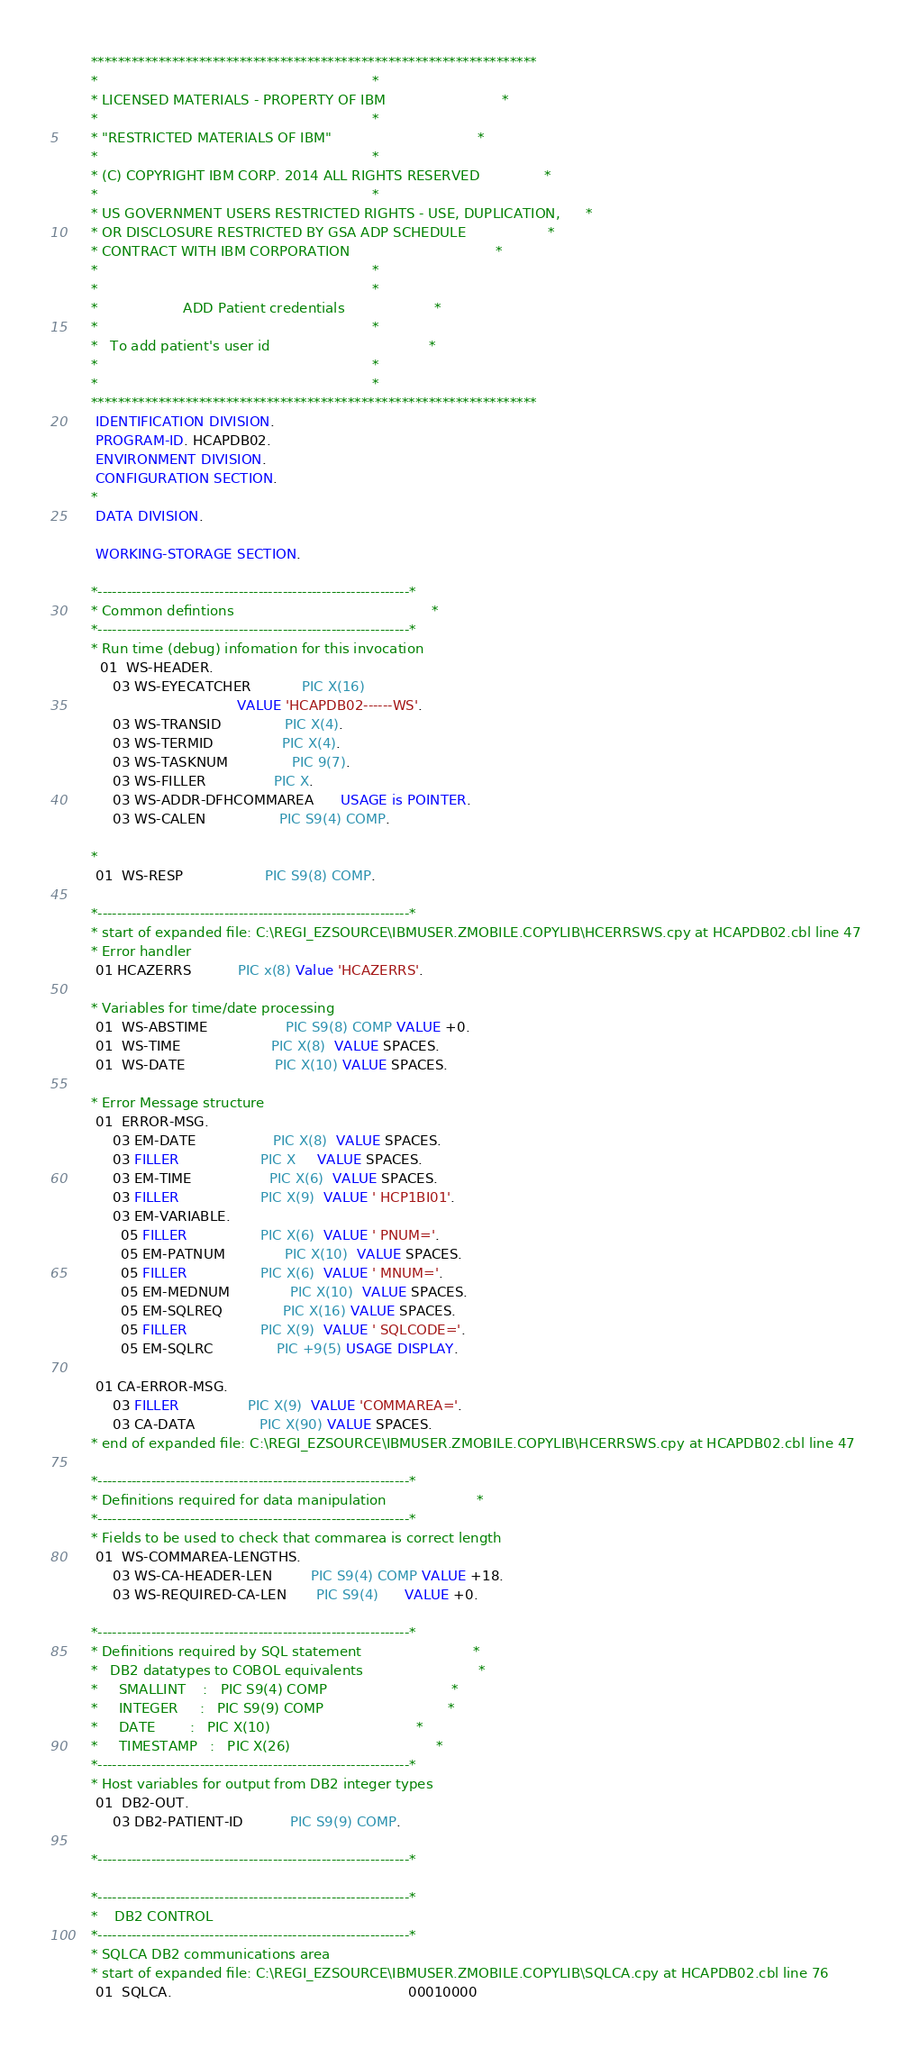Convert code to text. <code><loc_0><loc_0><loc_500><loc_500><_COBOL_>      ******************************************************************
      *                                                                *
      * LICENSED MATERIALS - PROPERTY OF IBM                           *
      *                                                                *
      * "RESTRICTED MATERIALS OF IBM"                                  *
      *                                                                *
      * (C) COPYRIGHT IBM CORP. 2014 ALL RIGHTS RESERVED               *
      *                                                                *
      * US GOVERNMENT USERS RESTRICTED RIGHTS - USE, DUPLICATION,      *
      * OR DISCLOSURE RESTRICTED BY GSA ADP SCHEDULE                   *
      * CONTRACT WITH IBM CORPORATION                                  *
      *                                                                *
      *                                                                *
      *                    ADD Patient credentials                     *
      *                                                                *
      *   To add patient's user id                                     *
      *                                                                *
      *                                                                *
      ******************************************************************
       IDENTIFICATION DIVISION.
       PROGRAM-ID. HCAPDB02.
       ENVIRONMENT DIVISION.
       CONFIGURATION SECTION.
      *
       DATA DIVISION.

       WORKING-STORAGE SECTION.

      *----------------------------------------------------------------*
      * Common defintions                                              *
      *----------------------------------------------------------------*
      * Run time (debug) infomation for this invocation
        01  WS-HEADER.
           03 WS-EYECATCHER            PIC X(16)
                                        VALUE 'HCAPDB02------WS'.
           03 WS-TRANSID               PIC X(4).
           03 WS-TERMID                PIC X(4).
           03 WS-TASKNUM               PIC 9(7).
           03 WS-FILLER                PIC X.
           03 WS-ADDR-DFHCOMMAREA      USAGE is POINTER.
           03 WS-CALEN                 PIC S9(4) COMP.

      *
       01  WS-RESP                   PIC S9(8) COMP.

      *----------------------------------------------------------------*
      * start of expanded file: C:\REGI_EZSOURCE\IBMUSER.ZMOBILE.COPYLIB\HCERRSWS.cpy at HCAPDB02.cbl line 47
      * Error handler
       01 HCAZERRS           PIC x(8) Value 'HCAZERRS'.

      * Variables for time/date processing
       01  WS-ABSTIME                  PIC S9(8) COMP VALUE +0.
       01  WS-TIME                     PIC X(8)  VALUE SPACES.
       01  WS-DATE                     PIC X(10) VALUE SPACES.

      * Error Message structure
       01  ERROR-MSG.
           03 EM-DATE                  PIC X(8)  VALUE SPACES.
           03 FILLER                   PIC X     VALUE SPACES.
           03 EM-TIME                  PIC X(6)  VALUE SPACES.
           03 FILLER                   PIC X(9)  VALUE ' HCP1BI01'.
           03 EM-VARIABLE.
             05 FILLER                 PIC X(6)  VALUE ' PNUM='.
             05 EM-PATNUM              PIC X(10)  VALUE SPACES.
             05 FILLER                 PIC X(6)  VALUE ' MNUM='.
             05 EM-MEDNUM              PIC X(10)  VALUE SPACES.
             05 EM-SQLREQ              PIC X(16) VALUE SPACES.
             05 FILLER                 PIC X(9)  VALUE ' SQLCODE='.
             05 EM-SQLRC               PIC +9(5) USAGE DISPLAY.

       01 CA-ERROR-MSG.
           03 FILLER                PIC X(9)  VALUE 'COMMAREA='.
           03 CA-DATA               PIC X(90) VALUE SPACES.
      * end of expanded file: C:\REGI_EZSOURCE\IBMUSER.ZMOBILE.COPYLIB\HCERRSWS.cpy at HCAPDB02.cbl line 47

      *----------------------------------------------------------------*
      * Definitions required for data manipulation                     *
      *----------------------------------------------------------------*
      * Fields to be used to check that commarea is correct length
       01  WS-COMMAREA-LENGTHS.
           03 WS-CA-HEADER-LEN         PIC S9(4) COMP VALUE +18.
           03 WS-REQUIRED-CA-LEN       PIC S9(4)      VALUE +0.

      *----------------------------------------------------------------*
      * Definitions required by SQL statement                          *
      *   DB2 datatypes to COBOL equivalents                           *
      *     SMALLINT    :   PIC S9(4) COMP                             *
      *     INTEGER     :   PIC S9(9) COMP                             *
      *     DATE        :   PIC X(10)                                  *
      *     TIMESTAMP   :   PIC X(26)                                  *
      *----------------------------------------------------------------*
      * Host variables for output from DB2 integer types
       01  DB2-OUT.
           03 DB2-PATIENT-ID           PIC S9(9) COMP.

      *----------------------------------------------------------------*

      *----------------------------------------------------------------*
      *    DB2 CONTROL
      *----------------------------------------------------------------*
      * SQLCA DB2 communications area
      * start of expanded file: C:\REGI_EZSOURCE\IBMUSER.ZMOBILE.COPYLIB\SQLCA.cpy at HCAPDB02.cbl line 76
       01  SQLCA.                                                       00010000</code> 